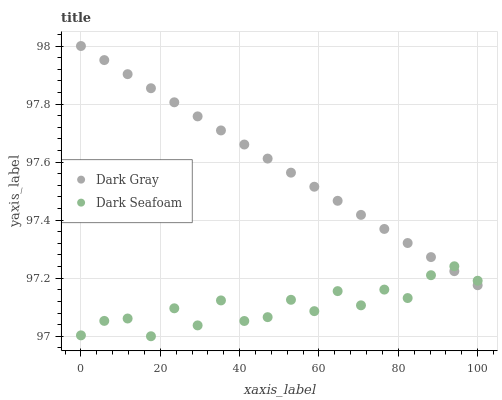Does Dark Seafoam have the minimum area under the curve?
Answer yes or no. Yes. Does Dark Gray have the maximum area under the curve?
Answer yes or no. Yes. Does Dark Seafoam have the maximum area under the curve?
Answer yes or no. No. Is Dark Gray the smoothest?
Answer yes or no. Yes. Is Dark Seafoam the roughest?
Answer yes or no. Yes. Is Dark Seafoam the smoothest?
Answer yes or no. No. Does Dark Seafoam have the lowest value?
Answer yes or no. Yes. Does Dark Gray have the highest value?
Answer yes or no. Yes. Does Dark Seafoam have the highest value?
Answer yes or no. No. Does Dark Seafoam intersect Dark Gray?
Answer yes or no. Yes. Is Dark Seafoam less than Dark Gray?
Answer yes or no. No. Is Dark Seafoam greater than Dark Gray?
Answer yes or no. No. 